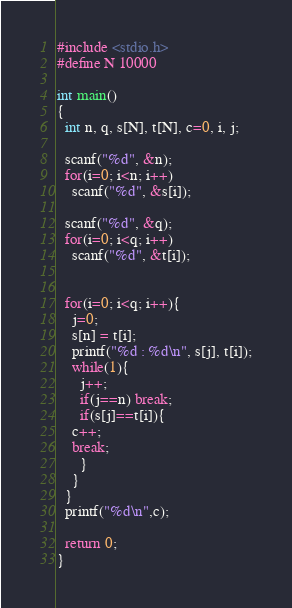Convert code to text. <code><loc_0><loc_0><loc_500><loc_500><_C_>#include <stdio.h>
#define N 10000

int main()
{
  int n, q, s[N], t[N], c=0, i, j;

  scanf("%d", &n);
  for(i=0; i<n; i++)
    scanf("%d", &s[i]);

  scanf("%d", &q);
  for(i=0; i<q; i++)
    scanf("%d", &t[i]);

  
  for(i=0; i<q; i++){
    j=0;
    s[n] = t[i];
    printf("%d : %d\n", s[j], t[i]);
    while(1){
      j++;
      if(j==n) break;
      if(s[j]==t[i]){
	c++;
	break;
      }
    }
  }
  printf("%d\n",c);

  return 0;
}</code> 